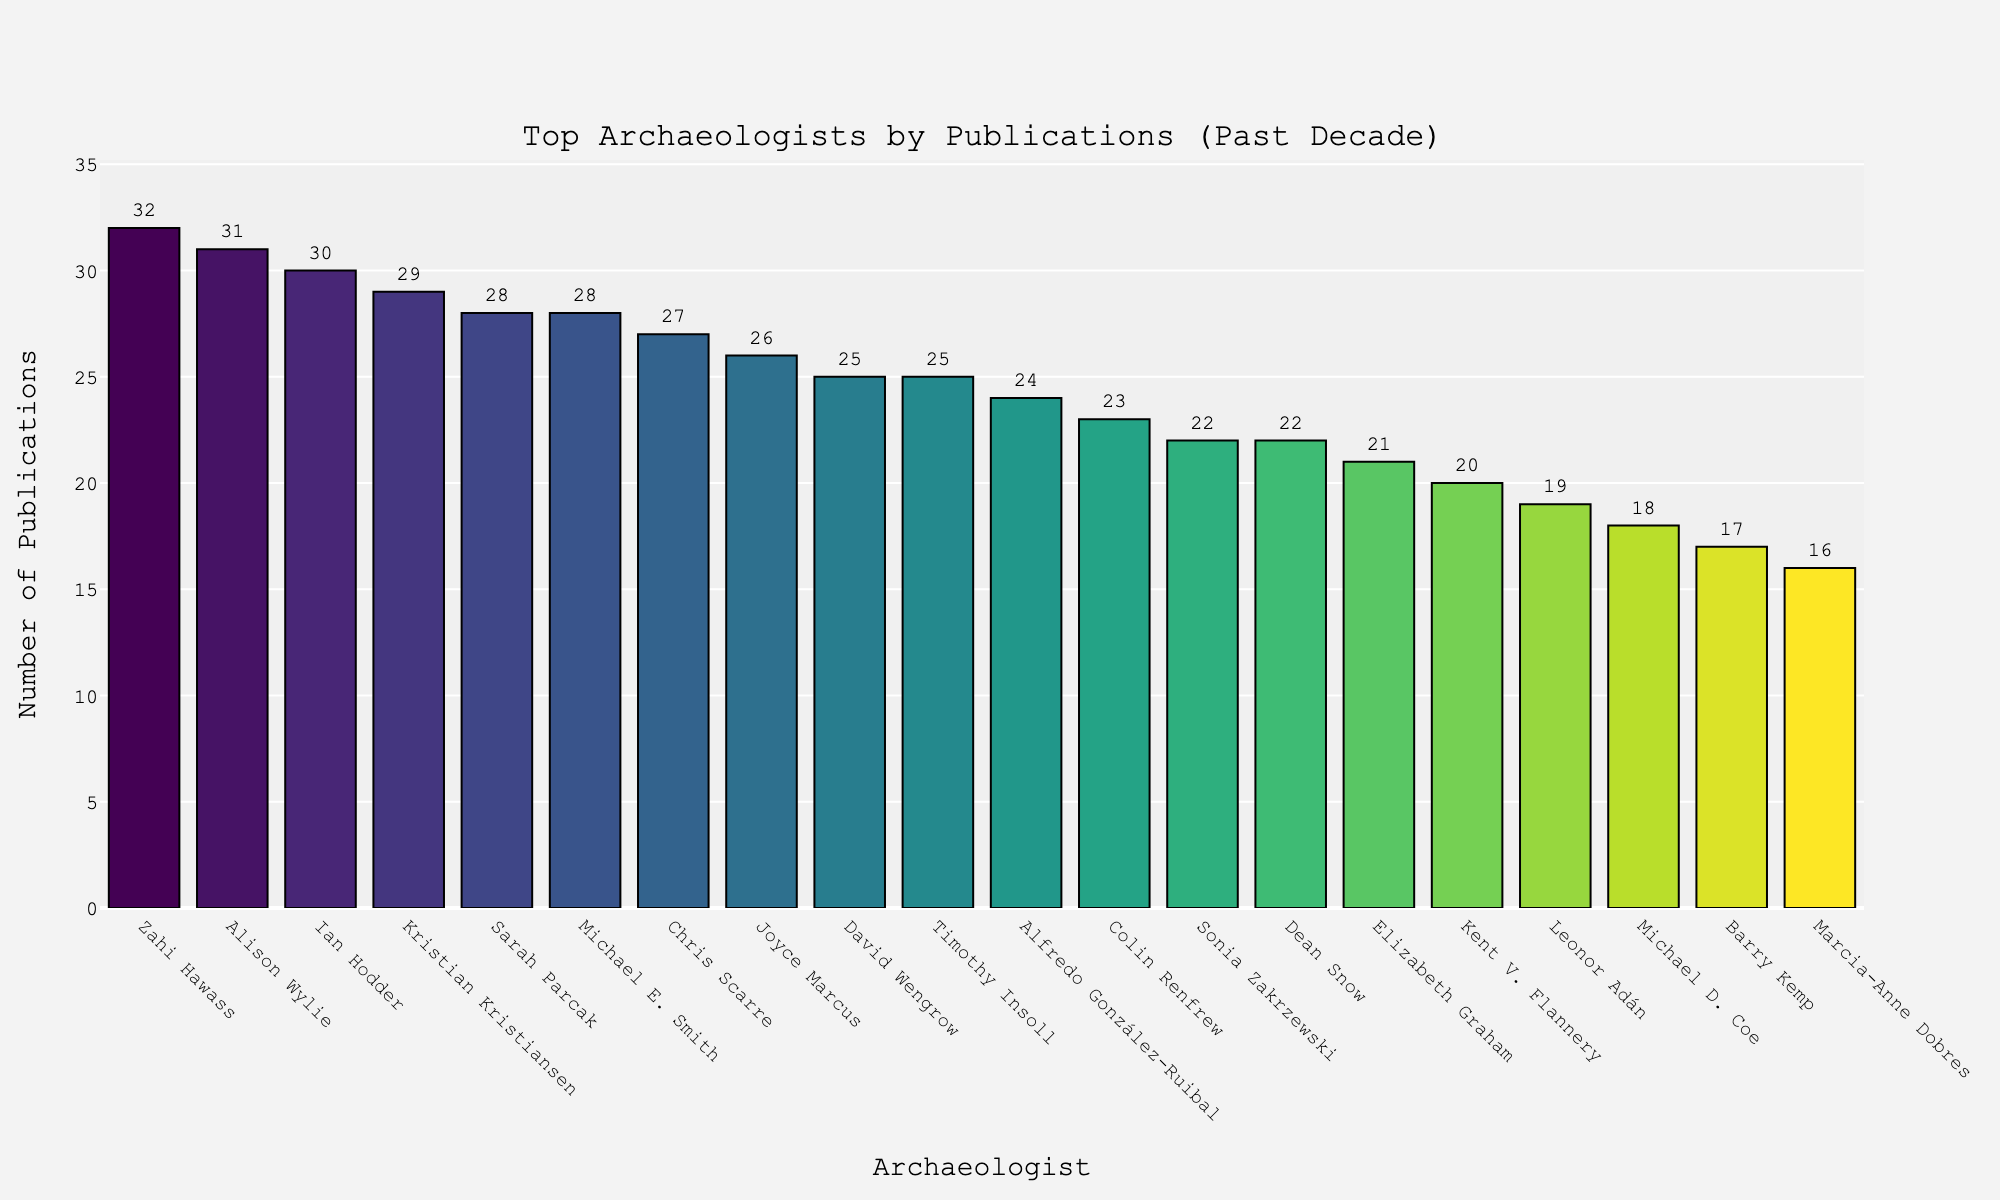Who has the highest number of publications? First, assess the bar heights representing publications by each archaeologist. The tallest bar is the one for Zahi Hawass with 32 publications.
Answer: Zahi Hawass Which archaeologist has fewer publications compared to Sarah Parcak and how many fewer? Find the bar for Sarah Parcak (28 publications). Below Sarah Parcak's bar, find David Wengrow with 25 publications. Subtract 25 (David Wengrow) from 28 (Sarah Parcak) to get the difference.
Answer: David Wengrow, 3 fewer What is the combined number of publications by the top three archaeologists? Identify the top three bars: Zahi Hawass (32), Alison Wylie (31), and Ian Hodder (30). Sum them up: 32 + 31 + 30 = 93.
Answer: 93 How many archaeologists have more than 20 publications but fewer than 30? Count the bars between the intervals 20 < Publications < 30: Sarah Parcak (28), Ian Hodder (30), Michael E. Smith (28), Krishna Kristiansen (29), and David Wengrow (25). There are five such archaeologists.
Answer: 5 Which two archaeologists have the same number of publications and what is that number? Scan the bars and find the matching heights. David Wengrow and Timothy Insoll both have 25 publications.
Answer: David Wengrow and Timothy Insoll, 25 Is Dean Snow's publication count more or less than Colin Renfrew's? By how much? Check the bars for Dean Snow (22 publications) and Colin Renfrew (23 publications). Subtract 22 (Dean Snow) from 23 (Colin Renfrew) to find the difference.
Answer: Less by 1 What is the difference in the number of publications between the archaeologist with the most and the least publications? The highest is Zahi Hawass with 32 publications, and the least is Marcia-Anne Dobres with 16 publications. Subtract: 32 - 16 = 16.
Answer: 16 How many different archaeologists have exactly 25 publications, and who are they? Identify the bars reaching 25: David Wengrow and Timothy Insoll. There are two archaeologists with 25 publications.
Answer: 2, David Wengrow and Timothy Insoll Among the given archaeologists, how many have published under 20 papers in the last decade? Count the bars with heights representing publications under 20: Leonor Adán (19), Michael D. Coe (18), Barry Kemp (17), and Marcia-Anne Dobres (16). There are four such archaeologists.
Answer: 4 